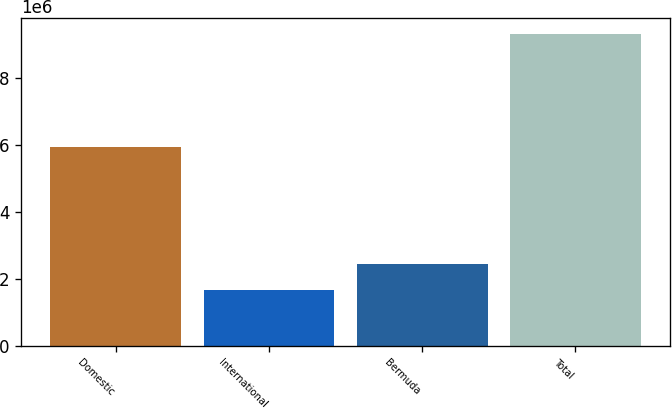Convert chart. <chart><loc_0><loc_0><loc_500><loc_500><bar_chart><fcel>Domestic<fcel>International<fcel>Bermuda<fcel>Total<nl><fcel>5.94471e+06<fcel>1.66593e+06<fcel>2.43336e+06<fcel>9.34018e+06<nl></chart> 